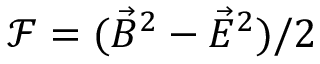Convert formula to latex. <formula><loc_0><loc_0><loc_500><loc_500>\mathcal { F } = ( \vec { B } ^ { 2 } - \vec { E } ^ { 2 } ) / 2</formula> 